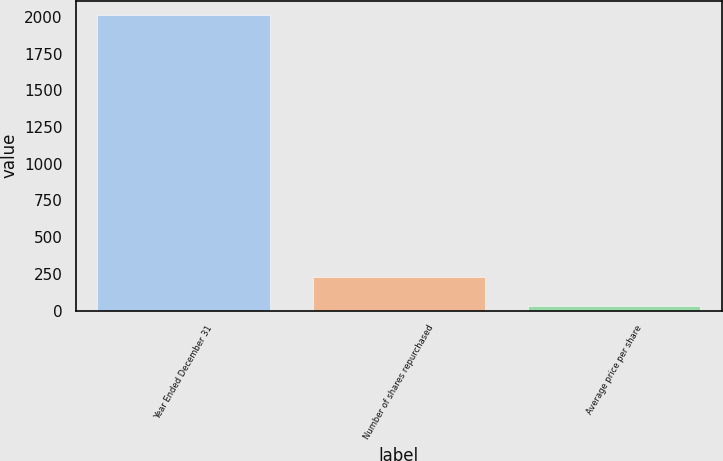Convert chart. <chart><loc_0><loc_0><loc_500><loc_500><bar_chart><fcel>Year Ended December 31<fcel>Number of shares repurchased<fcel>Average price per share<nl><fcel>2011<fcel>231.46<fcel>33.73<nl></chart> 